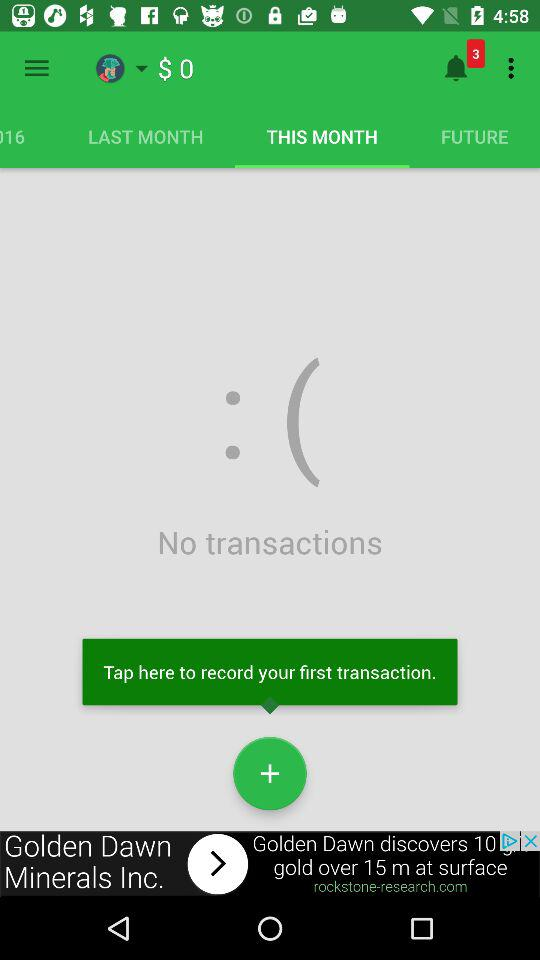How many transactions have I made?
Answer the question using a single word or phrase. 0 